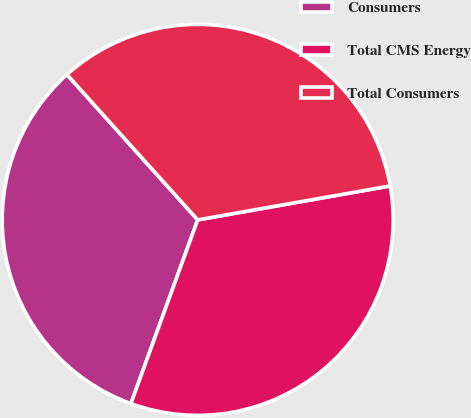Convert chart. <chart><loc_0><loc_0><loc_500><loc_500><pie_chart><fcel>Consumers<fcel>Total CMS Energy<fcel>Total Consumers<nl><fcel>32.79%<fcel>33.33%<fcel>33.88%<nl></chart> 